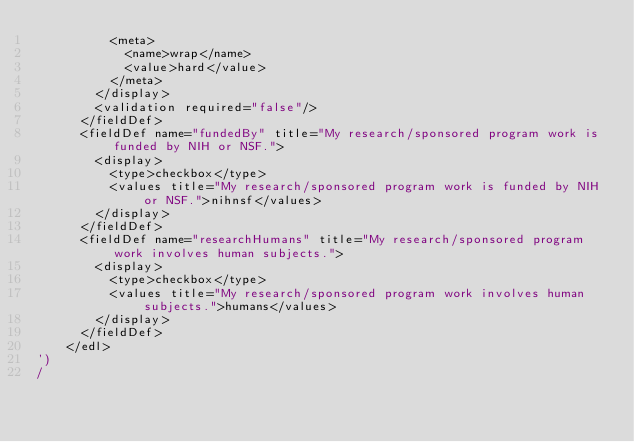<code> <loc_0><loc_0><loc_500><loc_500><_SQL_>          <meta>
            <name>wrap</name>
            <value>hard</value>
          </meta>
        </display>
        <validation required="false"/>
      </fieldDef>
      <fieldDef name="fundedBy" title="My research/sponsored program work is funded by NIH or NSF.">
        <display>
          <type>checkbox</type>
          <values title="My research/sponsored program work is funded by NIH or NSF.">nihnsf</values>
        </display>
      </fieldDef>
      <fieldDef name="researchHumans" title="My research/sponsored program work involves human subjects.">
        <display>
          <type>checkbox</type>
          <values title="My research/sponsored program work involves human subjects.">humans</values>
        </display>
      </fieldDef>
    </edl>
')
/
</code> 